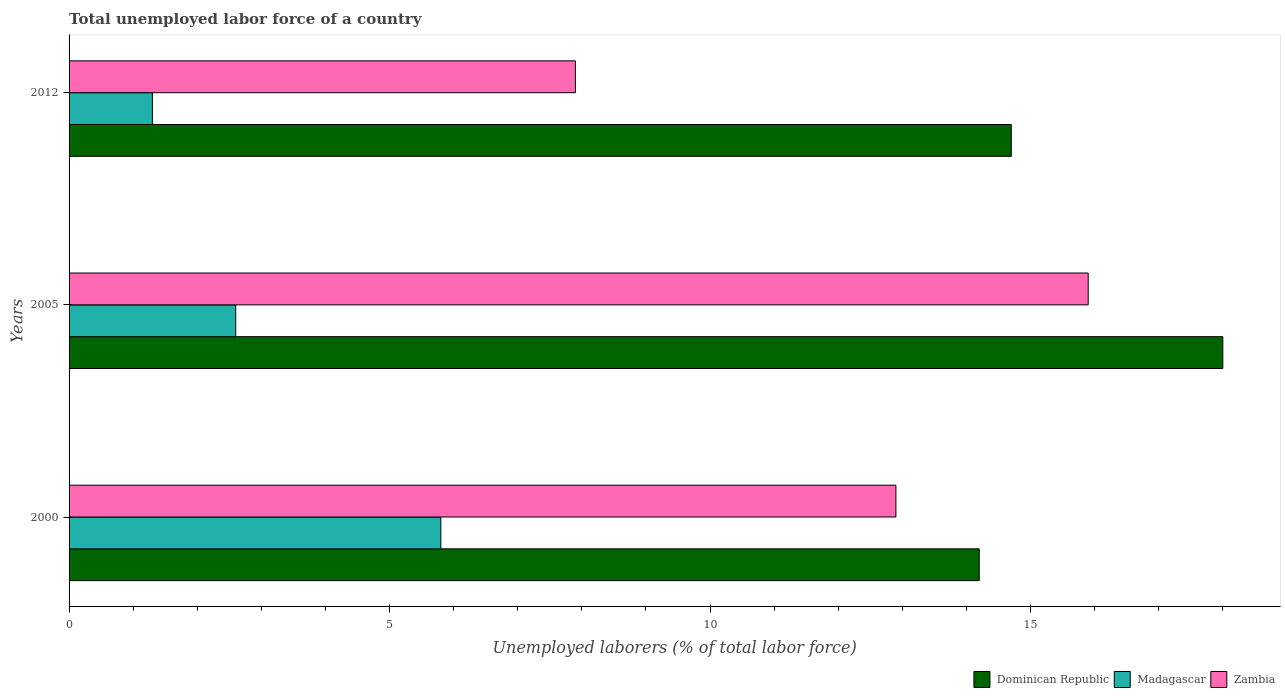What is the total unemployed labor force in Dominican Republic in 2000?
Provide a succinct answer. 14.2. Across all years, what is the maximum total unemployed labor force in Madagascar?
Your answer should be very brief. 5.8. Across all years, what is the minimum total unemployed labor force in Zambia?
Your answer should be very brief. 7.9. What is the total total unemployed labor force in Zambia in the graph?
Provide a succinct answer. 36.7. What is the difference between the total unemployed labor force in Dominican Republic in 2000 and that in 2005?
Your response must be concise. -3.8. What is the difference between the total unemployed labor force in Dominican Republic in 2005 and the total unemployed labor force in Zambia in 2000?
Provide a short and direct response. 5.1. What is the average total unemployed labor force in Zambia per year?
Your answer should be compact. 12.23. In the year 2012, what is the difference between the total unemployed labor force in Dominican Republic and total unemployed labor force in Madagascar?
Give a very brief answer. 13.4. What is the ratio of the total unemployed labor force in Madagascar in 2000 to that in 2012?
Provide a succinct answer. 4.46. Is the total unemployed labor force in Madagascar in 2000 less than that in 2005?
Your answer should be very brief. No. Is the difference between the total unemployed labor force in Dominican Republic in 2005 and 2012 greater than the difference between the total unemployed labor force in Madagascar in 2005 and 2012?
Keep it short and to the point. Yes. What is the difference between the highest and the second highest total unemployed labor force in Madagascar?
Provide a succinct answer. 3.2. What is the difference between the highest and the lowest total unemployed labor force in Madagascar?
Your answer should be compact. 4.5. What does the 3rd bar from the top in 2000 represents?
Ensure brevity in your answer.  Dominican Republic. What does the 2nd bar from the bottom in 2005 represents?
Give a very brief answer. Madagascar. Is it the case that in every year, the sum of the total unemployed labor force in Dominican Republic and total unemployed labor force in Madagascar is greater than the total unemployed labor force in Zambia?
Offer a very short reply. Yes. How many bars are there?
Keep it short and to the point. 9. Are all the bars in the graph horizontal?
Give a very brief answer. Yes. Are the values on the major ticks of X-axis written in scientific E-notation?
Keep it short and to the point. No. Does the graph contain any zero values?
Provide a succinct answer. No. What is the title of the graph?
Provide a succinct answer. Total unemployed labor force of a country. What is the label or title of the X-axis?
Provide a succinct answer. Unemployed laborers (% of total labor force). What is the Unemployed laborers (% of total labor force) in Dominican Republic in 2000?
Offer a terse response. 14.2. What is the Unemployed laborers (% of total labor force) in Madagascar in 2000?
Keep it short and to the point. 5.8. What is the Unemployed laborers (% of total labor force) of Zambia in 2000?
Provide a succinct answer. 12.9. What is the Unemployed laborers (% of total labor force) in Dominican Republic in 2005?
Your answer should be very brief. 18. What is the Unemployed laborers (% of total labor force) in Madagascar in 2005?
Your answer should be compact. 2.6. What is the Unemployed laborers (% of total labor force) of Zambia in 2005?
Your answer should be very brief. 15.9. What is the Unemployed laborers (% of total labor force) of Dominican Republic in 2012?
Provide a short and direct response. 14.7. What is the Unemployed laborers (% of total labor force) in Madagascar in 2012?
Your answer should be compact. 1.3. What is the Unemployed laborers (% of total labor force) in Zambia in 2012?
Offer a terse response. 7.9. Across all years, what is the maximum Unemployed laborers (% of total labor force) in Dominican Republic?
Your answer should be compact. 18. Across all years, what is the maximum Unemployed laborers (% of total labor force) in Madagascar?
Offer a very short reply. 5.8. Across all years, what is the maximum Unemployed laborers (% of total labor force) of Zambia?
Provide a short and direct response. 15.9. Across all years, what is the minimum Unemployed laborers (% of total labor force) of Dominican Republic?
Offer a very short reply. 14.2. Across all years, what is the minimum Unemployed laborers (% of total labor force) in Madagascar?
Offer a terse response. 1.3. Across all years, what is the minimum Unemployed laborers (% of total labor force) of Zambia?
Your answer should be very brief. 7.9. What is the total Unemployed laborers (% of total labor force) of Dominican Republic in the graph?
Offer a terse response. 46.9. What is the total Unemployed laborers (% of total labor force) of Madagascar in the graph?
Your answer should be compact. 9.7. What is the total Unemployed laborers (% of total labor force) of Zambia in the graph?
Offer a very short reply. 36.7. What is the difference between the Unemployed laborers (% of total labor force) in Dominican Republic in 2000 and that in 2005?
Provide a succinct answer. -3.8. What is the difference between the Unemployed laborers (% of total labor force) of Madagascar in 2000 and that in 2005?
Offer a very short reply. 3.2. What is the difference between the Unemployed laborers (% of total labor force) in Zambia in 2000 and that in 2005?
Provide a succinct answer. -3. What is the difference between the Unemployed laborers (% of total labor force) in Dominican Republic in 2000 and that in 2012?
Provide a succinct answer. -0.5. What is the difference between the Unemployed laborers (% of total labor force) in Madagascar in 2000 and that in 2012?
Provide a short and direct response. 4.5. What is the difference between the Unemployed laborers (% of total labor force) in Dominican Republic in 2005 and that in 2012?
Offer a terse response. 3.3. What is the difference between the Unemployed laborers (% of total labor force) of Zambia in 2005 and that in 2012?
Your answer should be very brief. 8. What is the difference between the Unemployed laborers (% of total labor force) of Dominican Republic in 2000 and the Unemployed laborers (% of total labor force) of Zambia in 2012?
Offer a very short reply. 6.3. What is the difference between the Unemployed laborers (% of total labor force) in Madagascar in 2000 and the Unemployed laborers (% of total labor force) in Zambia in 2012?
Make the answer very short. -2.1. What is the difference between the Unemployed laborers (% of total labor force) of Dominican Republic in 2005 and the Unemployed laborers (% of total labor force) of Madagascar in 2012?
Provide a short and direct response. 16.7. What is the difference between the Unemployed laborers (% of total labor force) of Madagascar in 2005 and the Unemployed laborers (% of total labor force) of Zambia in 2012?
Make the answer very short. -5.3. What is the average Unemployed laborers (% of total labor force) of Dominican Republic per year?
Provide a succinct answer. 15.63. What is the average Unemployed laborers (% of total labor force) of Madagascar per year?
Keep it short and to the point. 3.23. What is the average Unemployed laborers (% of total labor force) of Zambia per year?
Offer a terse response. 12.23. In the year 2000, what is the difference between the Unemployed laborers (% of total labor force) in Dominican Republic and Unemployed laborers (% of total labor force) in Madagascar?
Make the answer very short. 8.4. In the year 2000, what is the difference between the Unemployed laborers (% of total labor force) of Dominican Republic and Unemployed laborers (% of total labor force) of Zambia?
Offer a terse response. 1.3. In the year 2000, what is the difference between the Unemployed laborers (% of total labor force) of Madagascar and Unemployed laborers (% of total labor force) of Zambia?
Give a very brief answer. -7.1. In the year 2005, what is the difference between the Unemployed laborers (% of total labor force) of Dominican Republic and Unemployed laborers (% of total labor force) of Zambia?
Offer a very short reply. 2.1. In the year 2012, what is the difference between the Unemployed laborers (% of total labor force) of Dominican Republic and Unemployed laborers (% of total labor force) of Madagascar?
Provide a short and direct response. 13.4. In the year 2012, what is the difference between the Unemployed laborers (% of total labor force) of Dominican Republic and Unemployed laborers (% of total labor force) of Zambia?
Make the answer very short. 6.8. In the year 2012, what is the difference between the Unemployed laborers (% of total labor force) in Madagascar and Unemployed laborers (% of total labor force) in Zambia?
Keep it short and to the point. -6.6. What is the ratio of the Unemployed laborers (% of total labor force) in Dominican Republic in 2000 to that in 2005?
Provide a succinct answer. 0.79. What is the ratio of the Unemployed laborers (% of total labor force) of Madagascar in 2000 to that in 2005?
Ensure brevity in your answer.  2.23. What is the ratio of the Unemployed laborers (% of total labor force) of Zambia in 2000 to that in 2005?
Provide a succinct answer. 0.81. What is the ratio of the Unemployed laborers (% of total labor force) in Madagascar in 2000 to that in 2012?
Make the answer very short. 4.46. What is the ratio of the Unemployed laborers (% of total labor force) in Zambia in 2000 to that in 2012?
Ensure brevity in your answer.  1.63. What is the ratio of the Unemployed laborers (% of total labor force) in Dominican Republic in 2005 to that in 2012?
Your answer should be very brief. 1.22. What is the ratio of the Unemployed laborers (% of total labor force) in Zambia in 2005 to that in 2012?
Provide a succinct answer. 2.01. What is the difference between the highest and the second highest Unemployed laborers (% of total labor force) in Madagascar?
Make the answer very short. 3.2. What is the difference between the highest and the second highest Unemployed laborers (% of total labor force) in Zambia?
Keep it short and to the point. 3. What is the difference between the highest and the lowest Unemployed laborers (% of total labor force) of Dominican Republic?
Your response must be concise. 3.8. What is the difference between the highest and the lowest Unemployed laborers (% of total labor force) of Madagascar?
Make the answer very short. 4.5. 